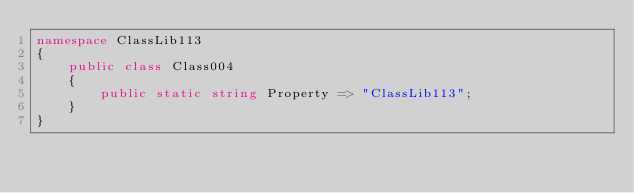<code> <loc_0><loc_0><loc_500><loc_500><_C#_>namespace ClassLib113
{
    public class Class004
    {
        public static string Property => "ClassLib113";
    }
}
</code> 